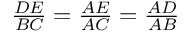<formula> <loc_0><loc_0><loc_500><loc_500>\frac { D E } { B C } = { \frac { A E } { A C } } = { \frac { A D } { A B } }</formula> 